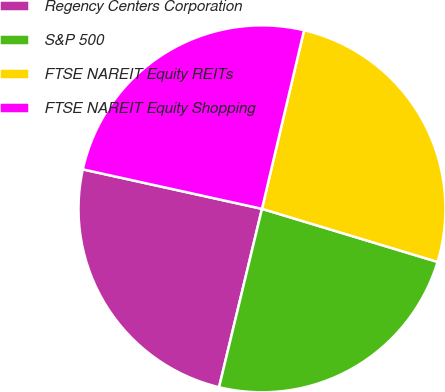Convert chart. <chart><loc_0><loc_0><loc_500><loc_500><pie_chart><fcel>Regency Centers Corporation<fcel>S&P 500<fcel>FTSE NAREIT Equity REITs<fcel>FTSE NAREIT Equity Shopping<nl><fcel>24.69%<fcel>24.08%<fcel>25.99%<fcel>25.23%<nl></chart> 